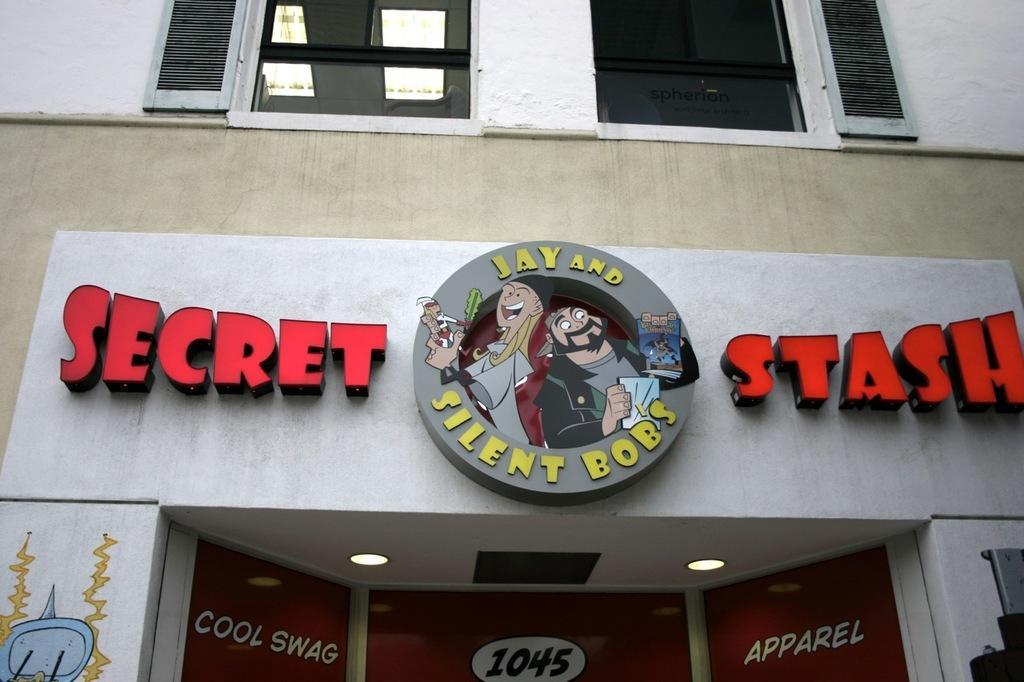How would you summarize this image in a sentence or two? As we can see in the image there is a building, windows and banners. 